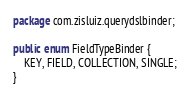Convert code to text. <code><loc_0><loc_0><loc_500><loc_500><_Java_>package com.zisluiz.querydslbinder;

public enum FieldTypeBinder {
	KEY, FIELD, COLLECTION, SINGLE;
}
</code> 